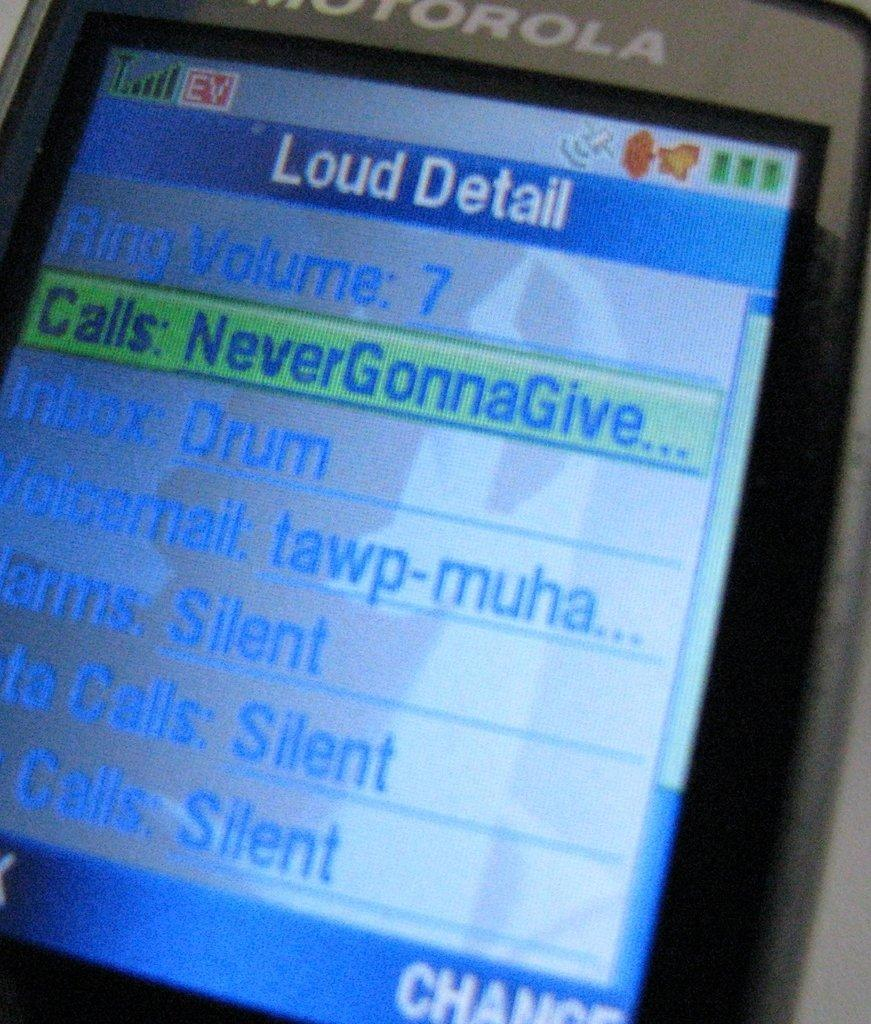<image>
Offer a succinct explanation of the picture presented. Motorola phone screen with the calls highlighted on it. 